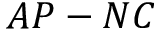Convert formula to latex. <formula><loc_0><loc_0><loc_500><loc_500>A P - N C</formula> 